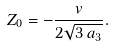Convert formula to latex. <formula><loc_0><loc_0><loc_500><loc_500>Z _ { 0 } = - \frac { v } { 2 \sqrt { 3 \, a _ { 3 } } } .</formula> 